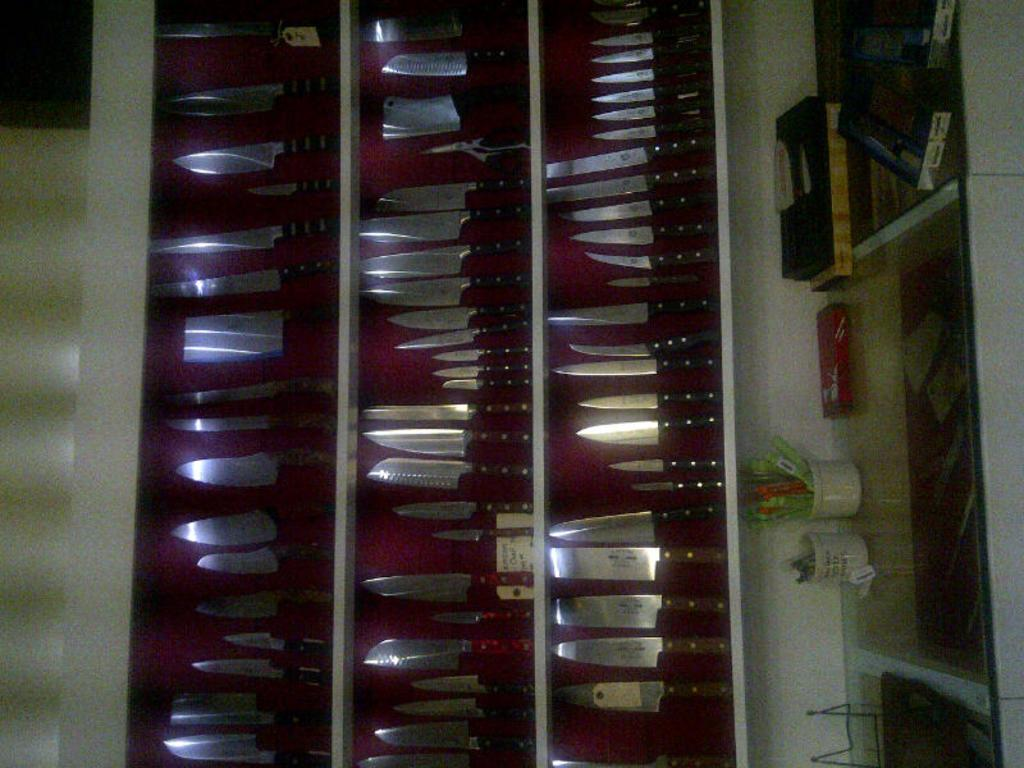What objects are hanging on the wall in the image? There are knives of various sizes on the wall. What piece of furniture is present in the image? There is a table in the image. What items can be seen on the table? The table has cups and boxes on it. How was the image taken? The image is taken in a vertical orientation. What type of meal is being prepared on the table in the image? There is no meal preparation visible in the image; it only shows knives on the wall, a table with cups and boxes, and the image's vertical orientation. 